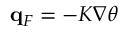<formula> <loc_0><loc_0><loc_500><loc_500>q _ { F } = - K \nabla \theta</formula> 